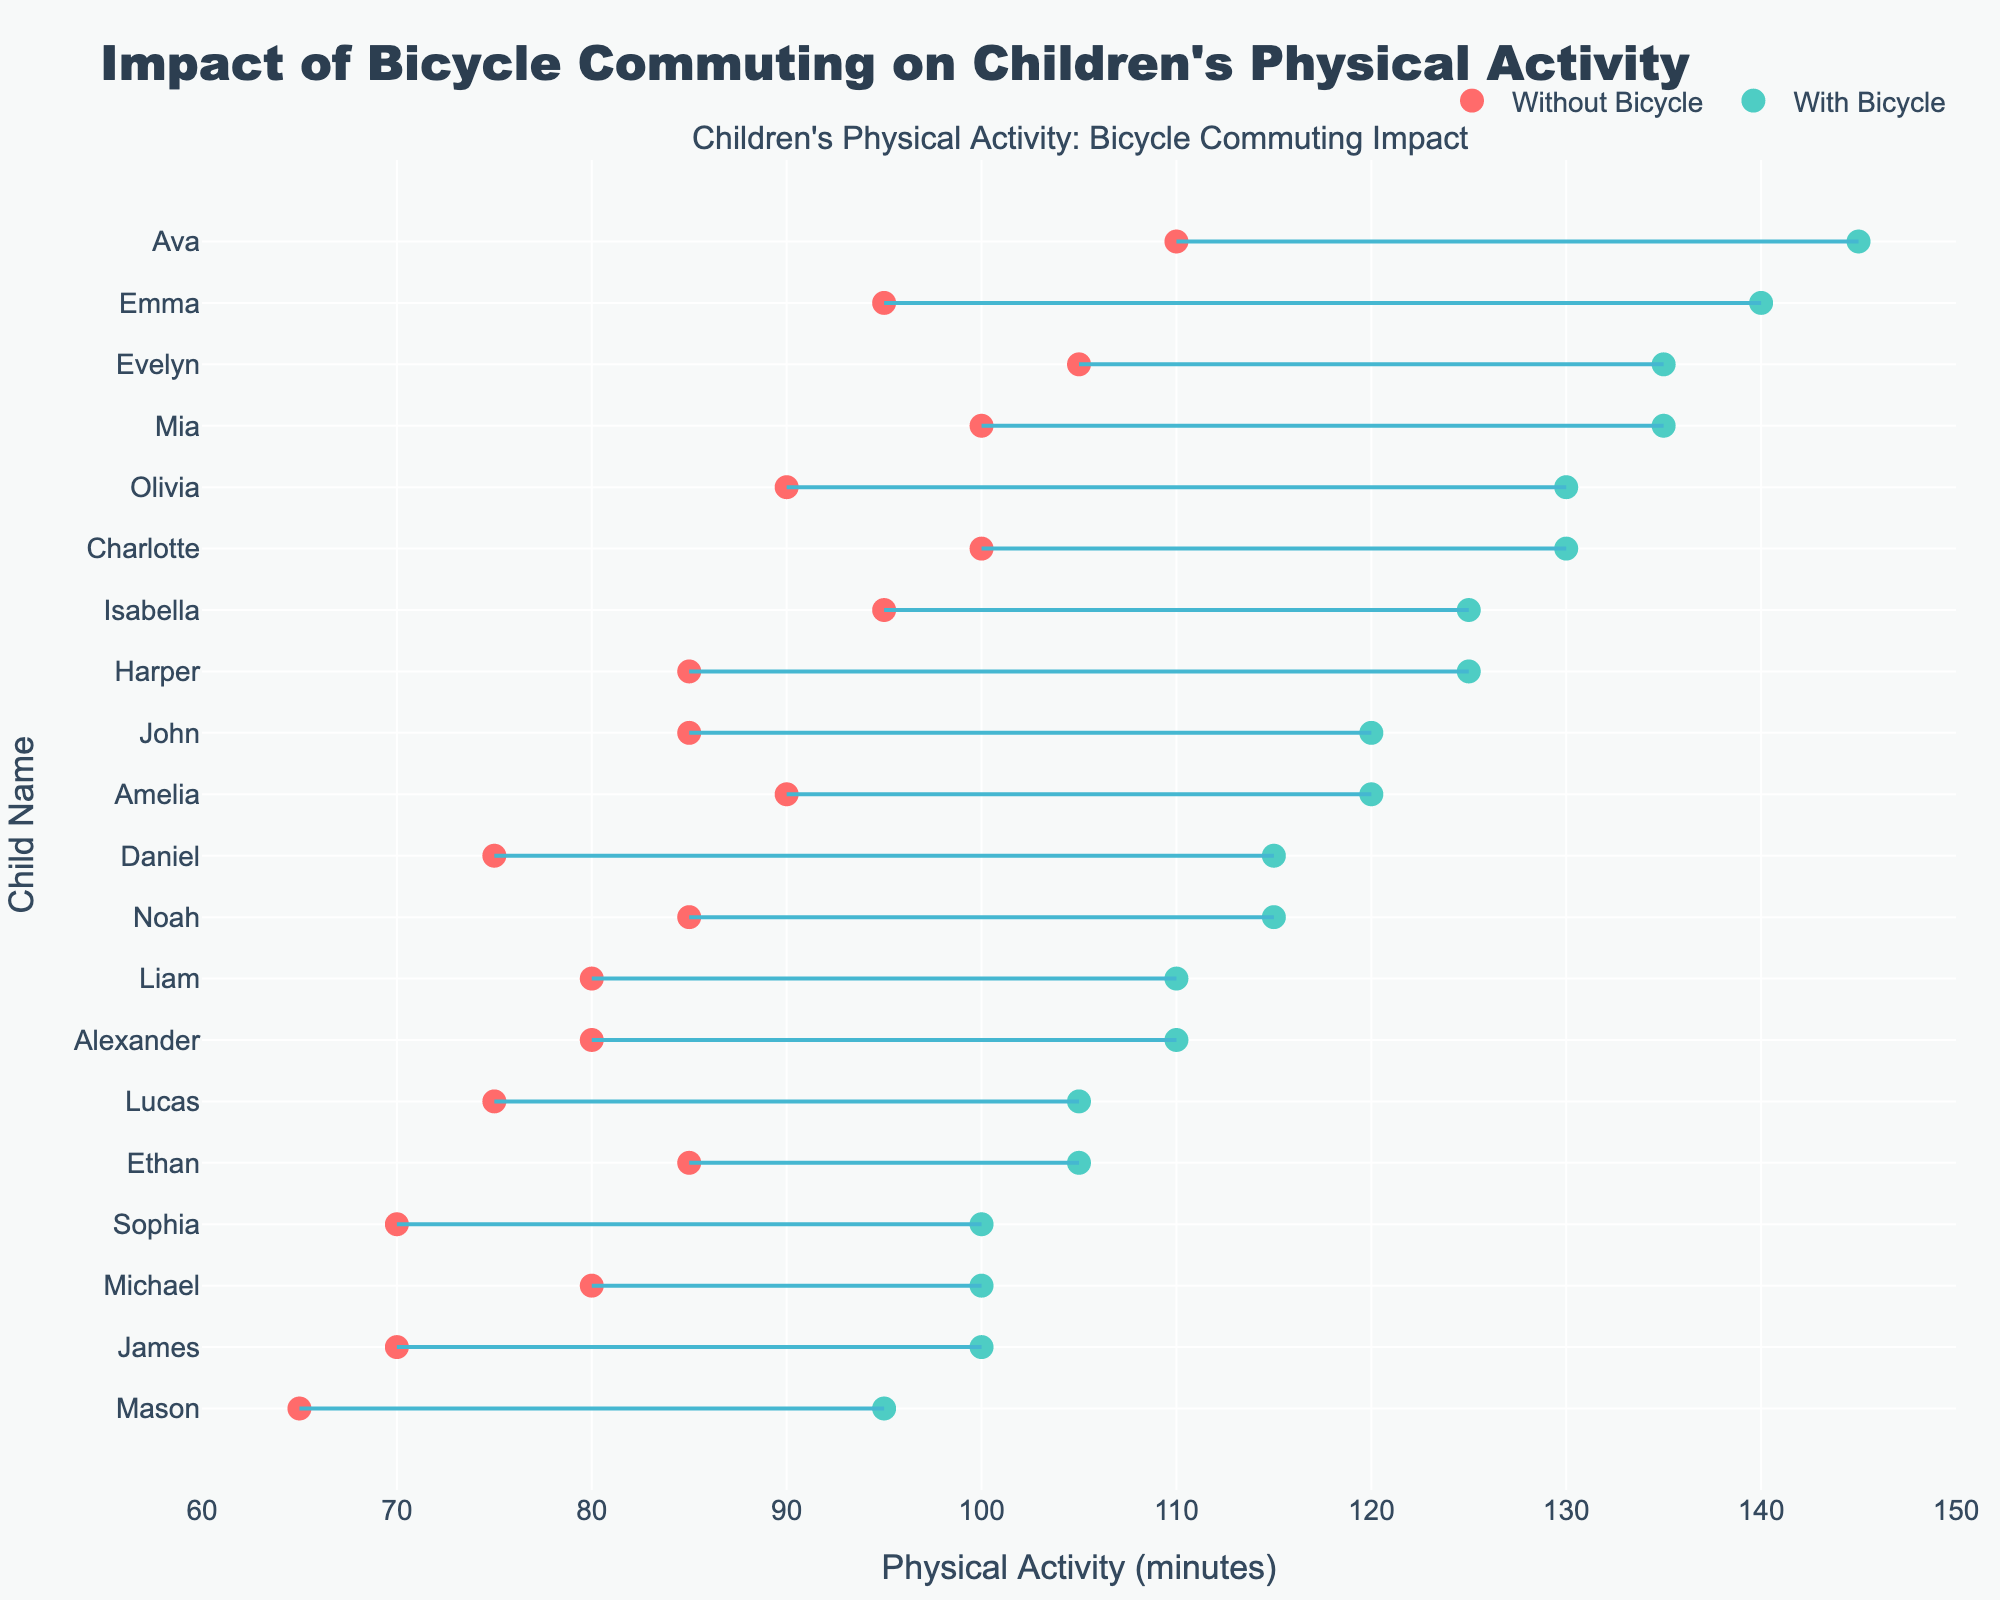What's the title of the plot? The title of the plot is mentioned at the top center of the figure.
Answer: Impact of Bicycle Commuting on Children's Physical Activity Which color represents 'With Bicycle' in the plot? The color used for 'With Bicycle' is mentioned in the legend, and the markers are consistently shown in that color in the plot.
Answer: Green How many children have physical activity data shown in the figure? There are markers paired with lines for each child, and the y-axis lists all the children's names.
Answer: 20 What is John’s physical activity level without bicycle commuting? Identify John's marker corresponding to the 'Without Bicycle' data point by its placement on the scale.
Answer: 85 minutes What is the difference in physical activity level for Sophia between days with and without bicycle commuting? Locate Sophia's markers for 'With Bicycle' and 'Without Bicycle', then calculate the difference between their values.
Answer: 30 minutes Which child has the highest increase in physical activity when using a bicycle? Compare the distances between the 'With Bicycle' and 'Without Bicycle' markers for each child and find the largest gap.
Answer: Ava Does every child increase their physical activity with bicycle commuting? Scan the plot to ensure that each 'With Bicycle' marker is consistently higher on the x-axis compared to its corresponding 'Without Bicycle' marker.
Answer: Yes Which child has the smallest difference in physical activity levels between the two conditions? Compare the differences for each child and identify the smallest gap between the 'With Bicycle' and 'Without Bicycle' markers.
Answer: Ethan On average, how much more physical activity do children get with bicycle commuting? Sum the differences between 'With Bicycle' and 'Without Bicycle' markers for all children, then divide by the number of children.
Answer: 30_minutes For which child is the physical activity level the same on both conditions? Check if any child’s markers for 'With Bicycle' and 'Without Bicycle' overlap or lie on the same vertical line.
Answer: None 